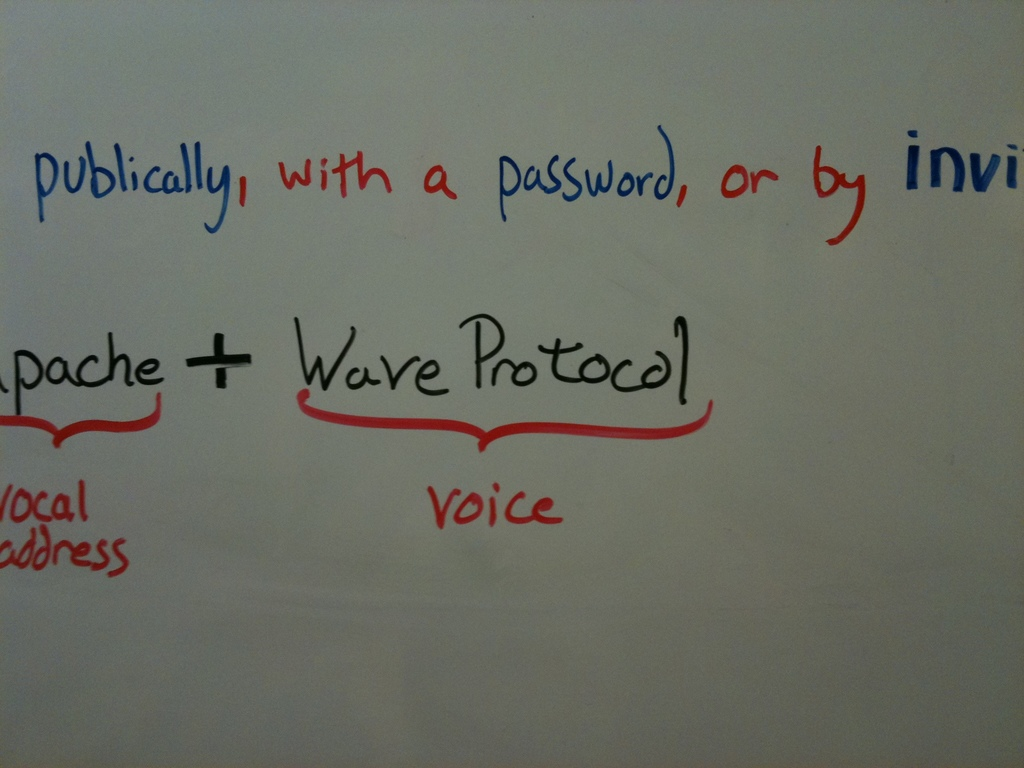What do you think is going on in this snapshot? The snapshot displays a whiteboard used in a discussion or presentation focusing on the 'Apache + Wave Protocol,' a framework for real-time collaborative editing. The words in red, such as 'voice' and 'local address,' suggest specific features or aspects of the protocol that are likely being emphasized or highlighted as important. Additionally, the text in blue outlines different modes of accessing the system, whether publicly, with a password, or through invitations, indicating multiple security or access options available in the software’s architecture. This detail implies a thorough brainstorming session or an educational scenario where participants are engaged in understanding or developing elements of the Apache Wave Protocol. 